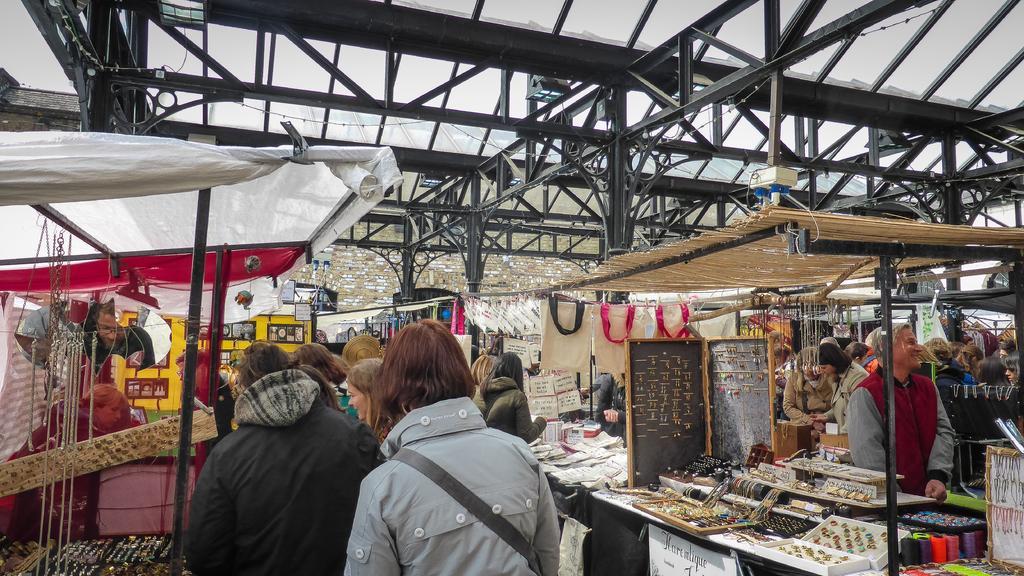In one or two sentences, can you explain what this image depicts? In this image I can see group of people standing. I can see few chains,earrings,rings,threads and some objects on the table. I can see tents and shed. 